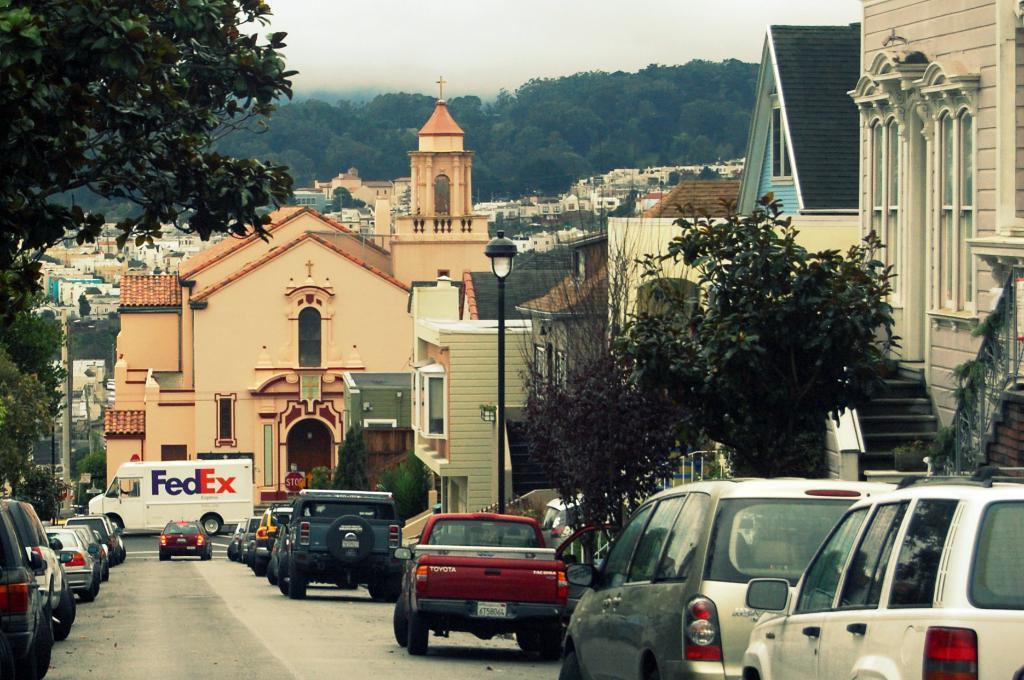How would you summarize this image in a sentence or two? In this image, there are some vehicles on the road. There is branch in the top left of the image. There are some buildings and pole in the middle of the image. There is a sky at the top of the image. 